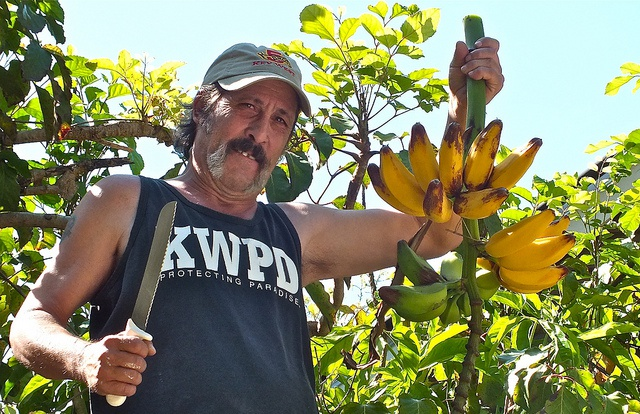Describe the objects in this image and their specific colors. I can see people in black, brown, and gray tones, banana in black, olive, maroon, and orange tones, banana in black, olive, and orange tones, knife in black, gray, and lightgray tones, and banana in black and darkgreen tones in this image. 